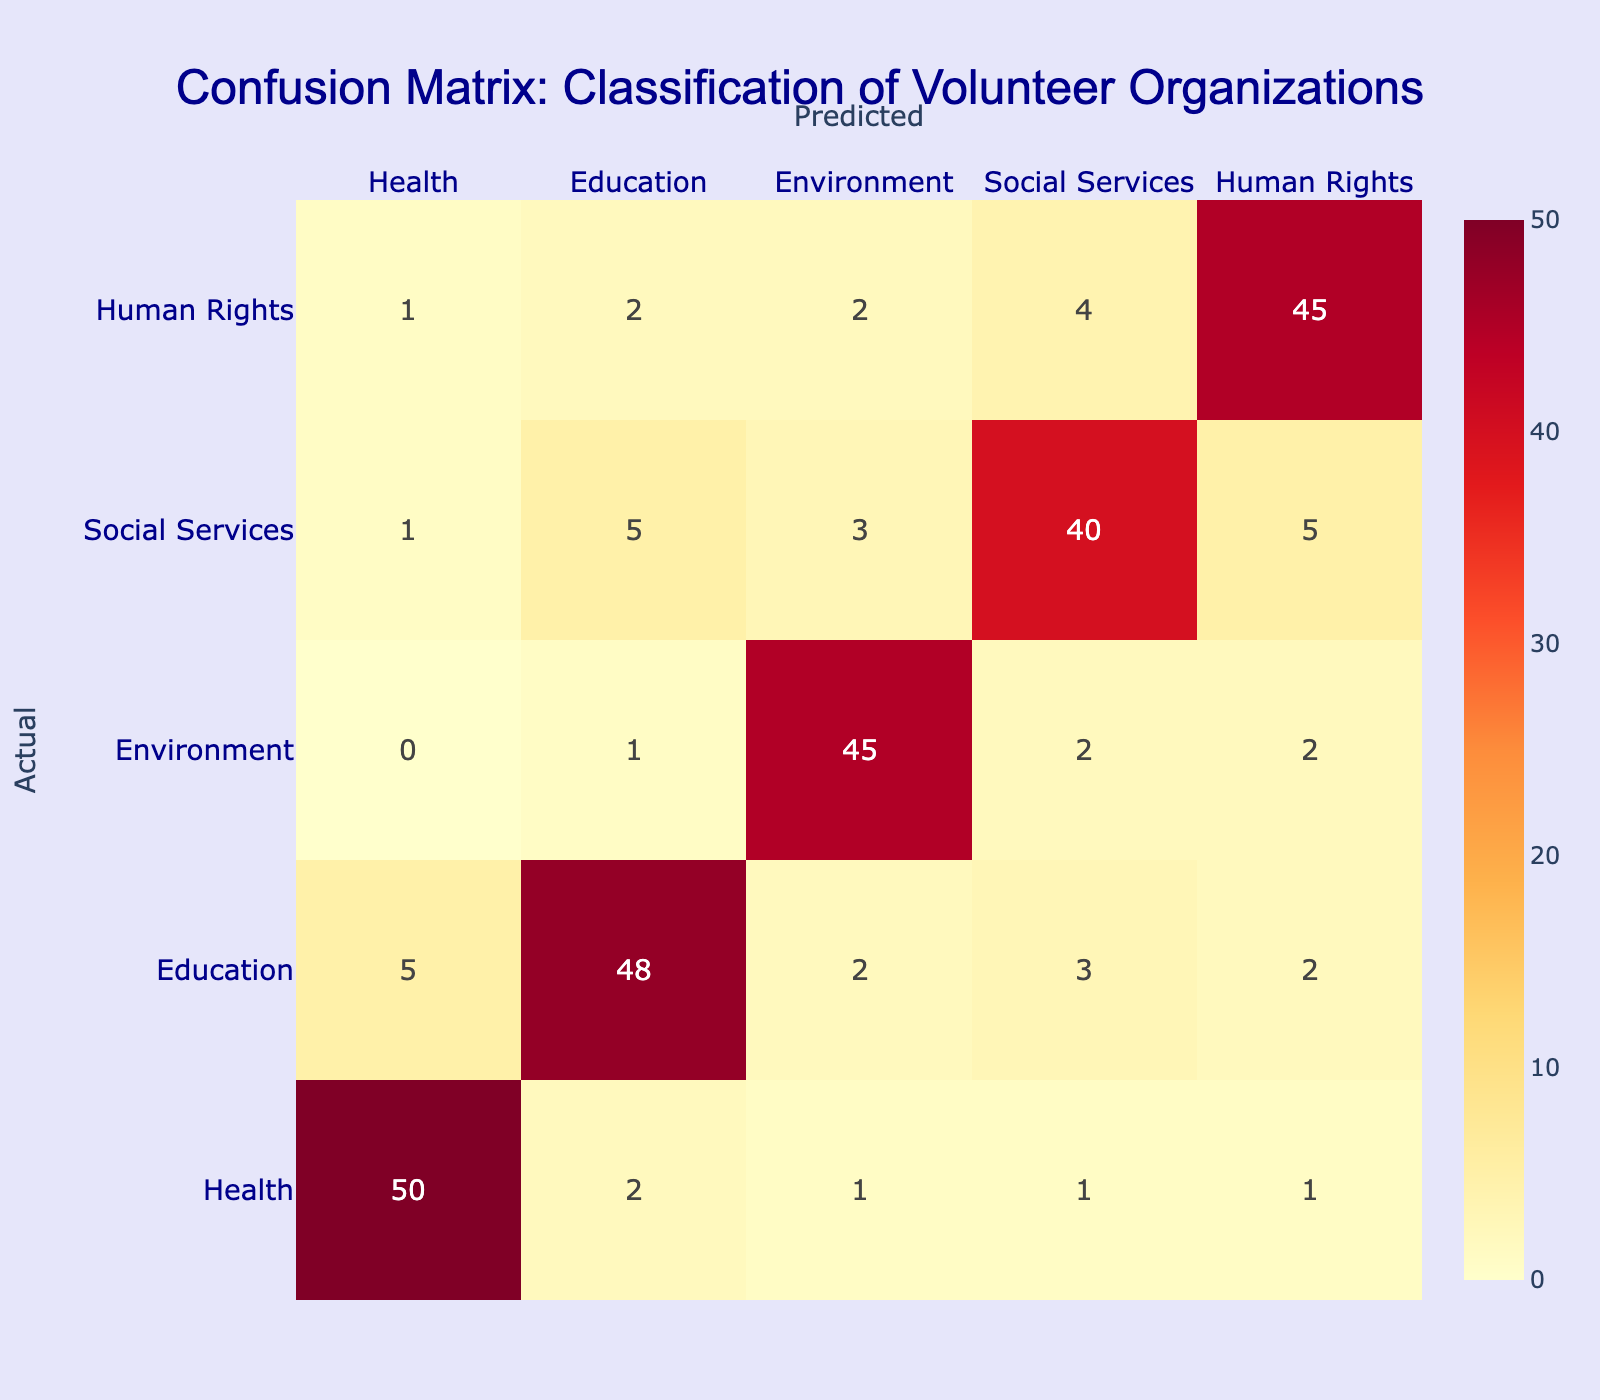What is the number of organizations that were correctly classified as Health? Looking at the row for Health, the value in the Health column is 50. This means that 50 organizations were accurately predicted to be in the Health sector.
Answer: 50 What is the total number of predicted organizations for the Education sector? To find this, we need to sum all values in the Education column. The values are 5 (Health), 48 (Education), 2 (Environment), 3 (Social Services), and 2 (Human Rights). The total is 5 + 48 + 2 + 3 + 2 = 60.
Answer: 60 Did more organizations get misclassified as Environment than as Social Services? Reviewing the Environment row, the misclassifications are 0 (Health), 1 (Education), 2 (Environment), 2 (Social Services), and 2 (Human Rights), which gives a total of 5. For Social Services, the misclassifications are 1 (Health), 5 (Education), 3 (Environment), 40 (Social Services), and 5 (Human Rights), totaling 14. Since 5 is less than 14, the answer is no.
Answer: No What percentage of actual Human Rights organizations were correctly classified? For the Human Rights row, the correctly classified organizations are 45. The total actual Human Rights organizations are 1 (Health), 2 (Education), 2 (Environment), 4 (Social Services), and 45 (Human Rights), which adds up to 54. Therefore, the percentage is (45/54) * 100 ≈ 83.33%.
Answer: Approximately 83.33% Is the confusion for the Human Rights sector greater than the total misclassification for the Environment sector? In the Human Rights row, the misclassifications are 1 (Health), 2 (Education), 2 (Environment), 4 (Social Services), totaling 9; while in the Environment row, it is 0 (Health), 1 (Education), 2 (Environment), 2 (Social Services), and 2 (Human Rights), totaling 7. Since 9 is greater than 7, the answer is yes.
Answer: Yes How many organizations were misclassified from Health to Education? From the Health row, the misclassified number transitioned to Education is 2, as seen directly in the corresponding cell of the table.
Answer: 2 What is the total number of actual organizations classified under Social Services? To find this total, we need to sum all entries in the Social Services row: 1 (Health), 5 (Education), 3 (Environment), 40 (Social Services), and 5 (Human Rights), giving a total of 54.
Answer: 54 How many fewer organizations were classified correctly in Education compared to those in Health? For Education, the correctly classified organizations are 48, while in Health, the correctly classified ones are 50. We find the difference: 50 - 48 = 2, which means 2 fewer were classified correctly in Education.
Answer: 2 